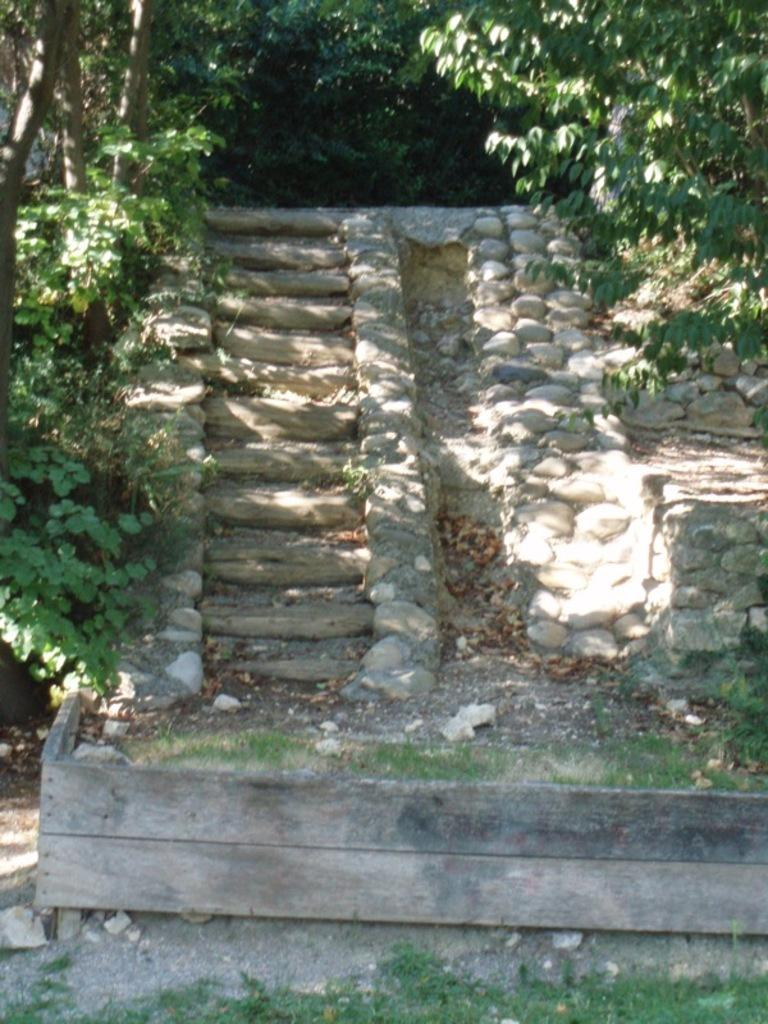What is the main feature in the center of the image? There are stairs in the center of the image. What can be seen on the right side of the image? There are stones on the right side of the image. What is visible in the background of the image? There are trees in the background of the image. How many goldfish can be seen swimming in the image? There are no goldfish present in the image. What type of corn is growing on the left side of the image? There is no corn present in the image. 